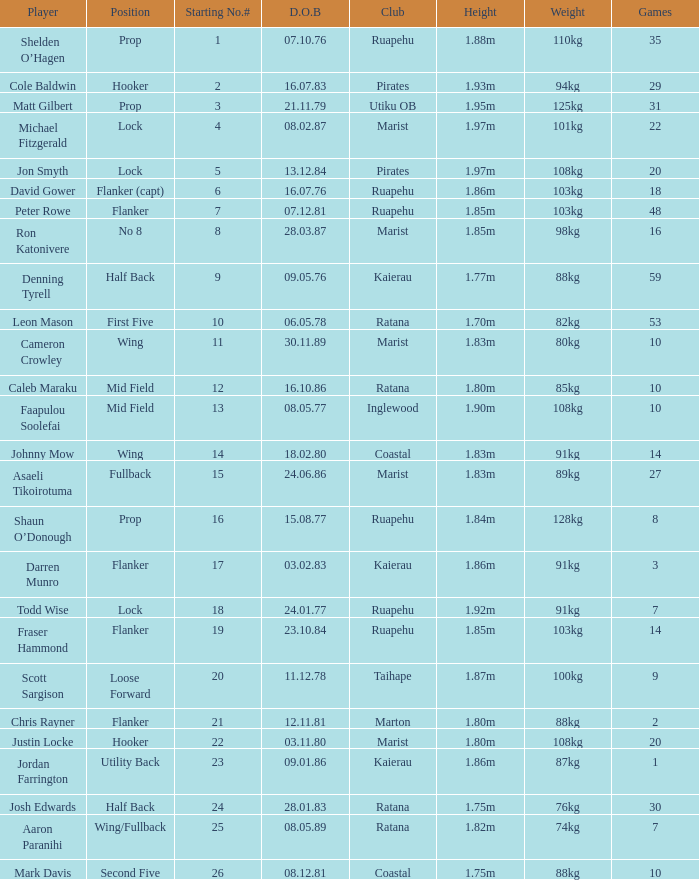How many games were played where the height of the player is 1.92m? 1.0. 